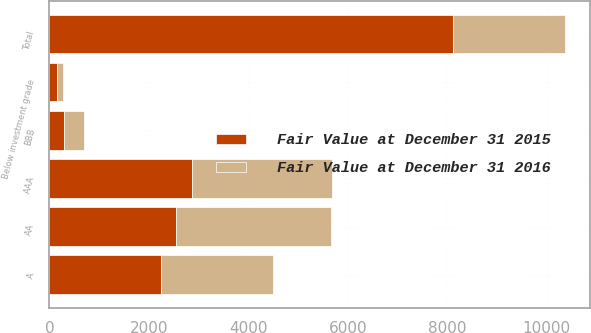Convert chart. <chart><loc_0><loc_0><loc_500><loc_500><stacked_bar_chart><ecel><fcel>AAA<fcel>AA<fcel>A<fcel>BBB<fcel>Below investment grade<fcel>Total<nl><fcel>Fair Value at December 31 2016<fcel>2805<fcel>3112<fcel>2244<fcel>395<fcel>121<fcel>2247<nl><fcel>Fair Value at December 31 2015<fcel>2870<fcel>2543<fcel>2247<fcel>298<fcel>157<fcel>8115<nl></chart> 